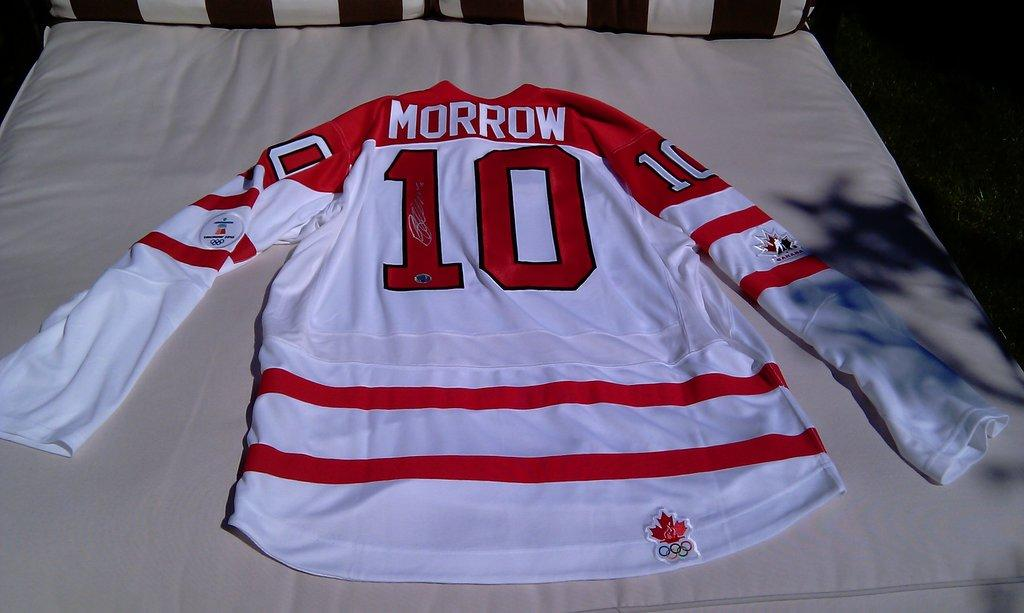Provide a one-sentence caption for the provided image. A red and white hockey jersey for someone named Morrow. 